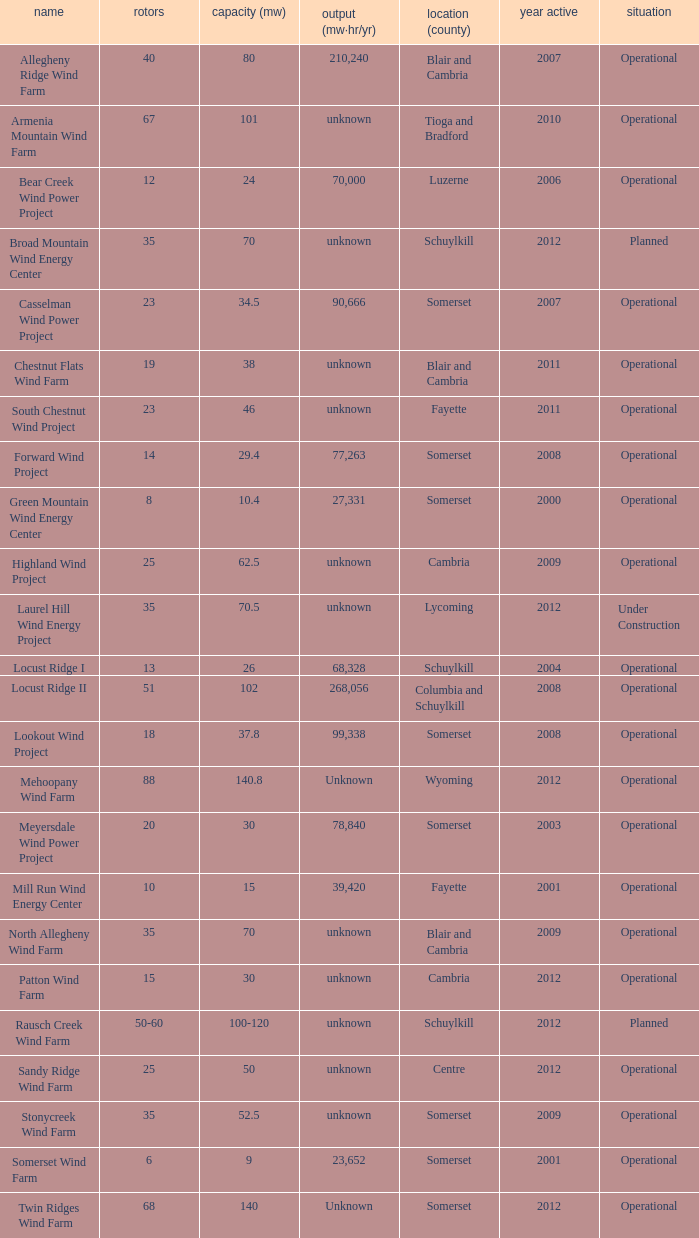What farm has a capacity of 70 and is operational? North Allegheny Wind Farm. 